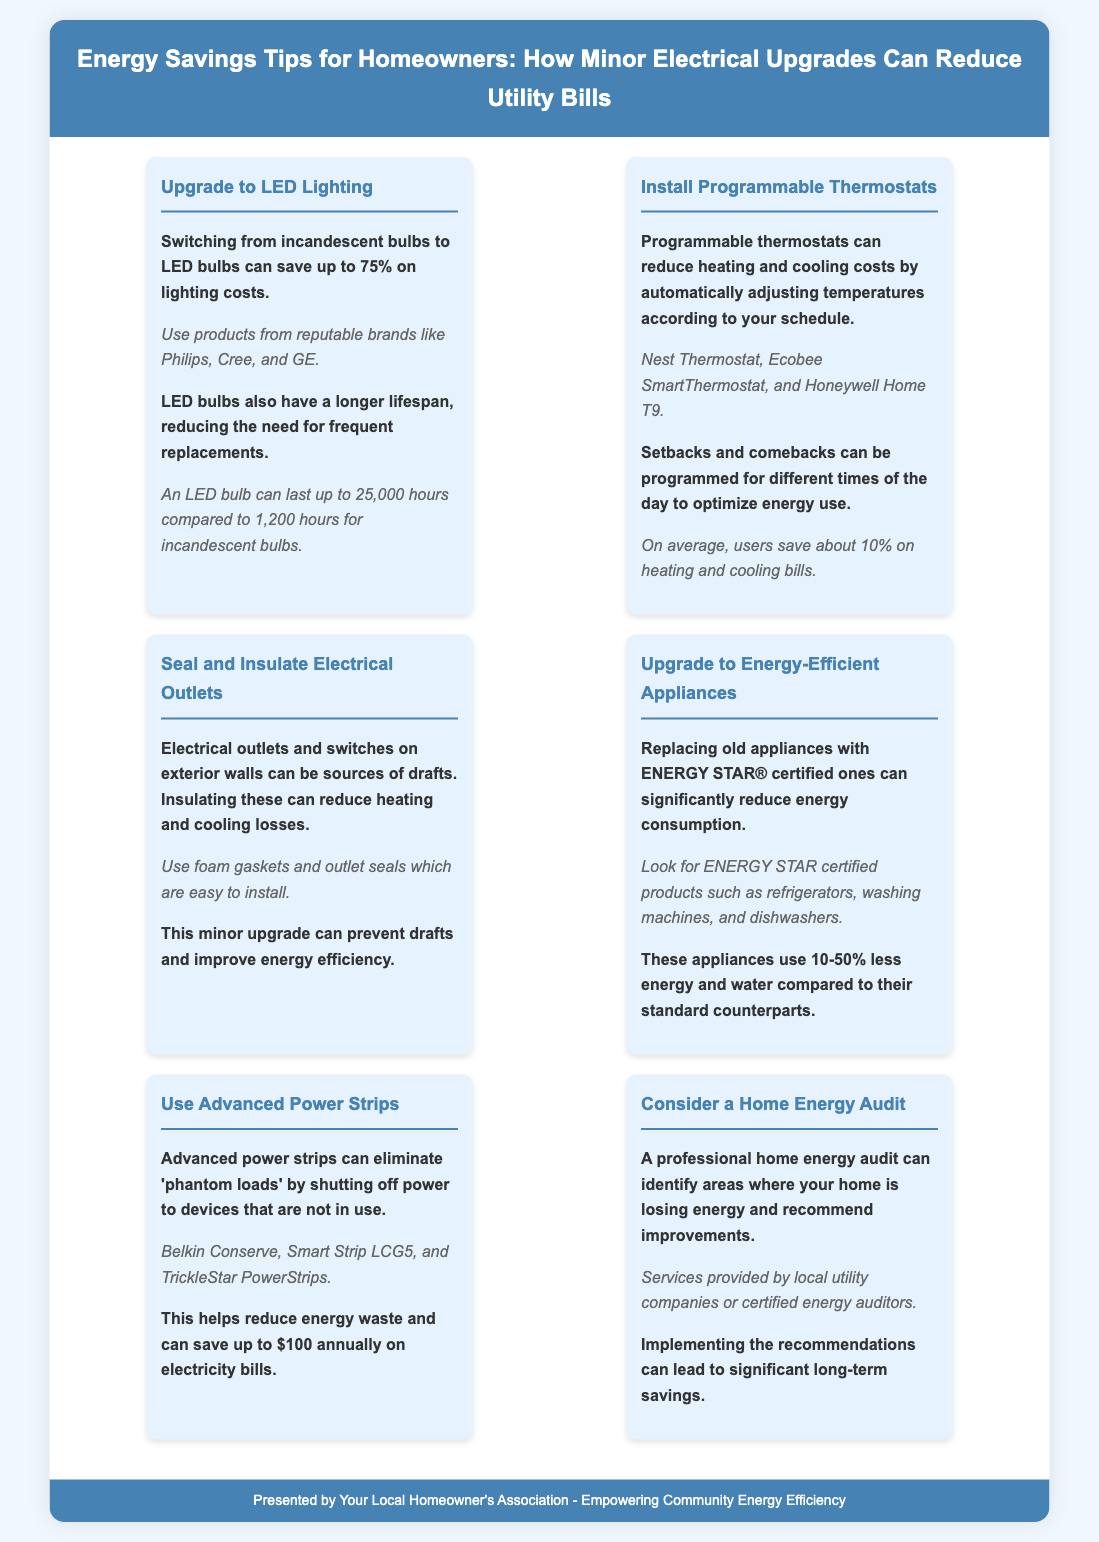what is the savings from upgrading to LED lighting? Switching from incandescent bulbs to LED bulbs can save up to 75% on lighting costs.
Answer: 75% how long can an LED bulb last compared to an incandescent bulb? An LED bulb can last up to 25,000 hours compared to 1,200 hours for incandescent bulbs.
Answer: 25,000 hours what percentage can programmable thermostats save on heating and cooling bills? On average, users save about 10% on heating and cooling bills.
Answer: 10% what type of appliances should be replaced with energy-efficient ones? Replace old appliances with ENERGY STAR® certified ones.
Answer: ENERGY STAR® what type of power strips can eliminate 'phantom loads'? Advanced power strips can eliminate 'phantom loads' by shutting off power to devices that are not in use.
Answer: Advanced power strips where can homeowners get a professional home energy audit? Services provided by local utility companies or certified energy auditors.
Answer: Local utility companies what can be used to insulate electrical outlets? Use foam gaskets and outlet seals which are easy to install.
Answer: Foam gaskets how much can using advanced power strips save annually? This helps reduce energy waste and can save up to $100 annually on electricity bills.
Answer: $100 